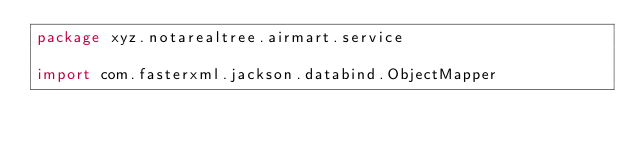Convert code to text. <code><loc_0><loc_0><loc_500><loc_500><_Kotlin_>package xyz.notarealtree.airmart.service

import com.fasterxml.jackson.databind.ObjectMapper</code> 